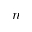Convert formula to latex. <formula><loc_0><loc_0><loc_500><loc_500>n</formula> 